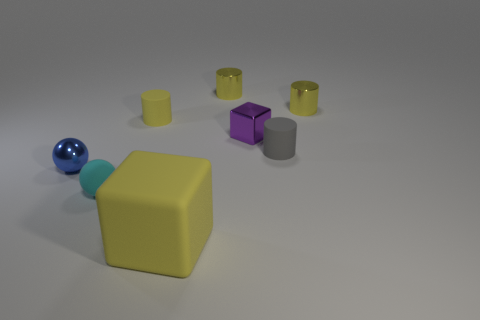Subtract all gray balls. How many yellow cylinders are left? 3 Add 2 tiny cyan rubber things. How many objects exist? 10 Subtract all balls. How many objects are left? 6 Add 4 yellow cubes. How many yellow cubes exist? 5 Subtract 0 purple cylinders. How many objects are left? 8 Subtract all tiny gray metallic cylinders. Subtract all large matte things. How many objects are left? 7 Add 8 tiny purple shiny cubes. How many tiny purple shiny cubes are left? 9 